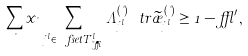<formula> <loc_0><loc_0><loc_500><loc_500>\sum _ { \nu } x _ { \nu } \, \sum _ { j ^ { l } \in \ f s e t { T } ^ { l } _ { \lambda , \delta } } \Lambda ^ { ( \nu ) } _ { j ^ { l } } \ t r \widetilde { \rho } ^ { ( \nu ) } _ { j ^ { l } } \geq 1 - \epsilon ^ { \prime } ,</formula> 